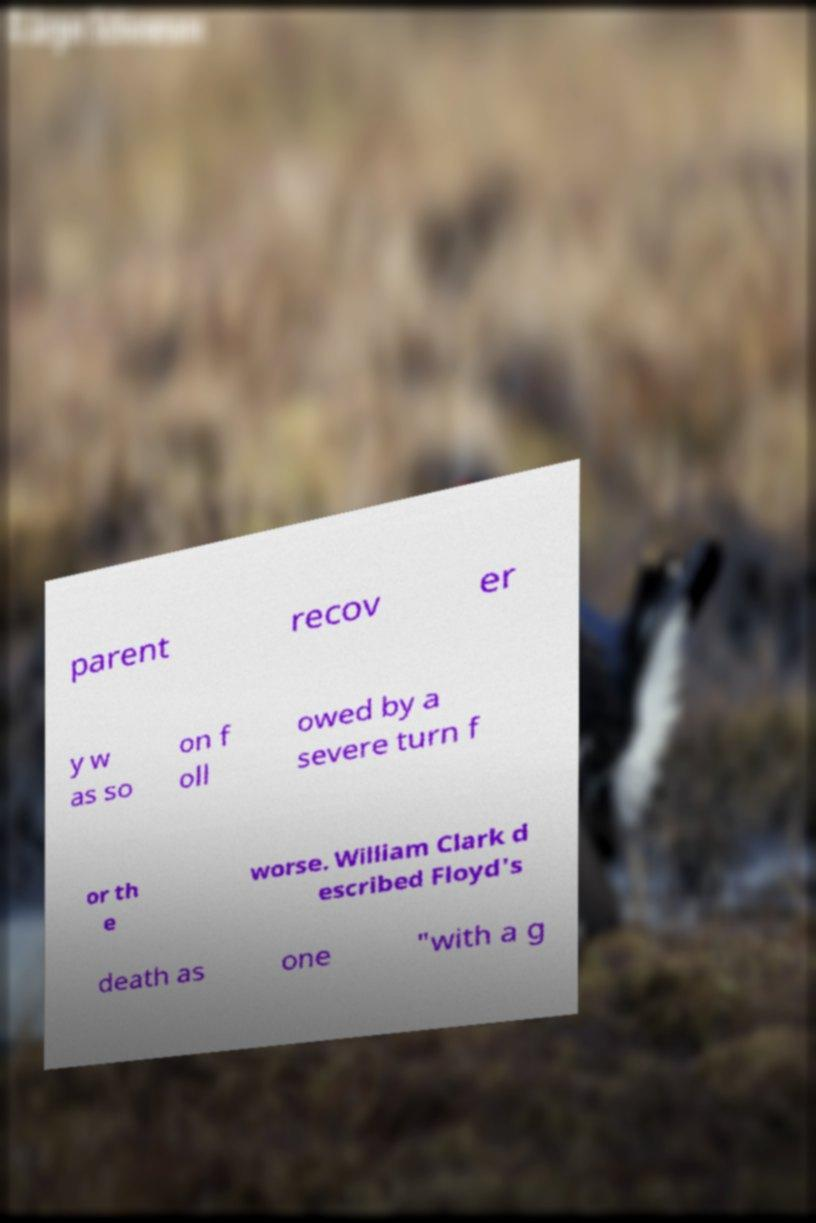Please read and relay the text visible in this image. What does it say? parent recov er y w as so on f oll owed by a severe turn f or th e worse. William Clark d escribed Floyd's death as one "with a g 